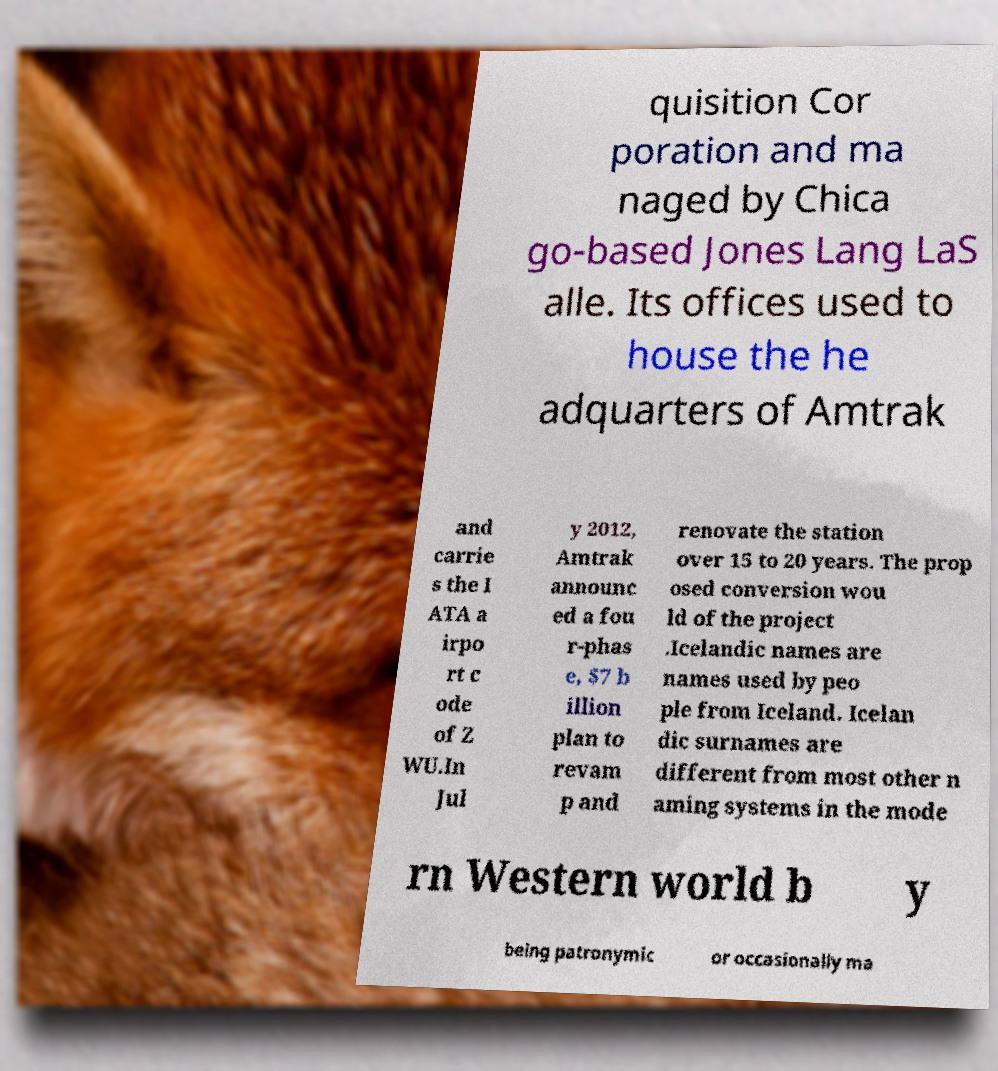Please read and relay the text visible in this image. What does it say? quisition Cor poration and ma naged by Chica go-based Jones Lang LaS alle. Its offices used to house the he adquarters of Amtrak and carrie s the I ATA a irpo rt c ode of Z WU.In Jul y 2012, Amtrak announc ed a fou r-phas e, $7 b illion plan to revam p and renovate the station over 15 to 20 years. The prop osed conversion wou ld of the project .Icelandic names are names used by peo ple from Iceland. Icelan dic surnames are different from most other n aming systems in the mode rn Western world b y being patronymic or occasionally ma 